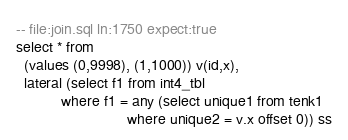<code> <loc_0><loc_0><loc_500><loc_500><_SQL_>-- file:join.sql ln:1750 expect:true
select * from
  (values (0,9998), (1,1000)) v(id,x),
  lateral (select f1 from int4_tbl
           where f1 = any (select unique1 from tenk1
                           where unique2 = v.x offset 0)) ss
</code> 